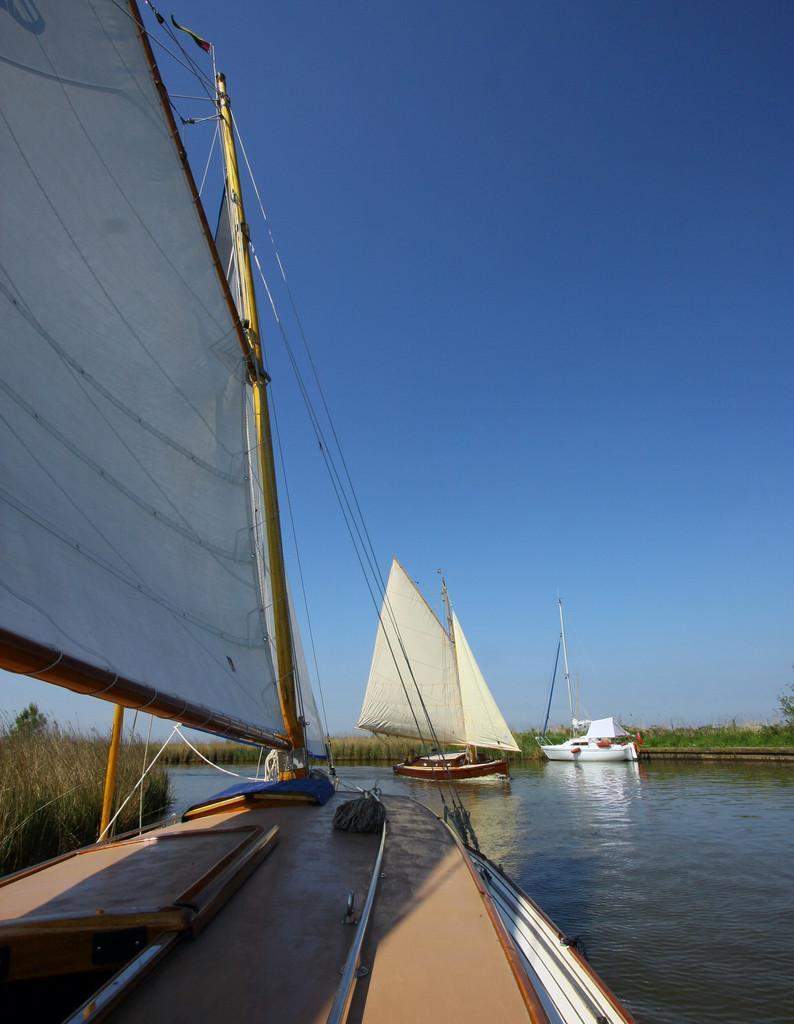Could you give a brief overview of what you see in this image? In this image, we can see some boats sailing on the water. We can also see some grass, plants and trees. We can also see the sky. 